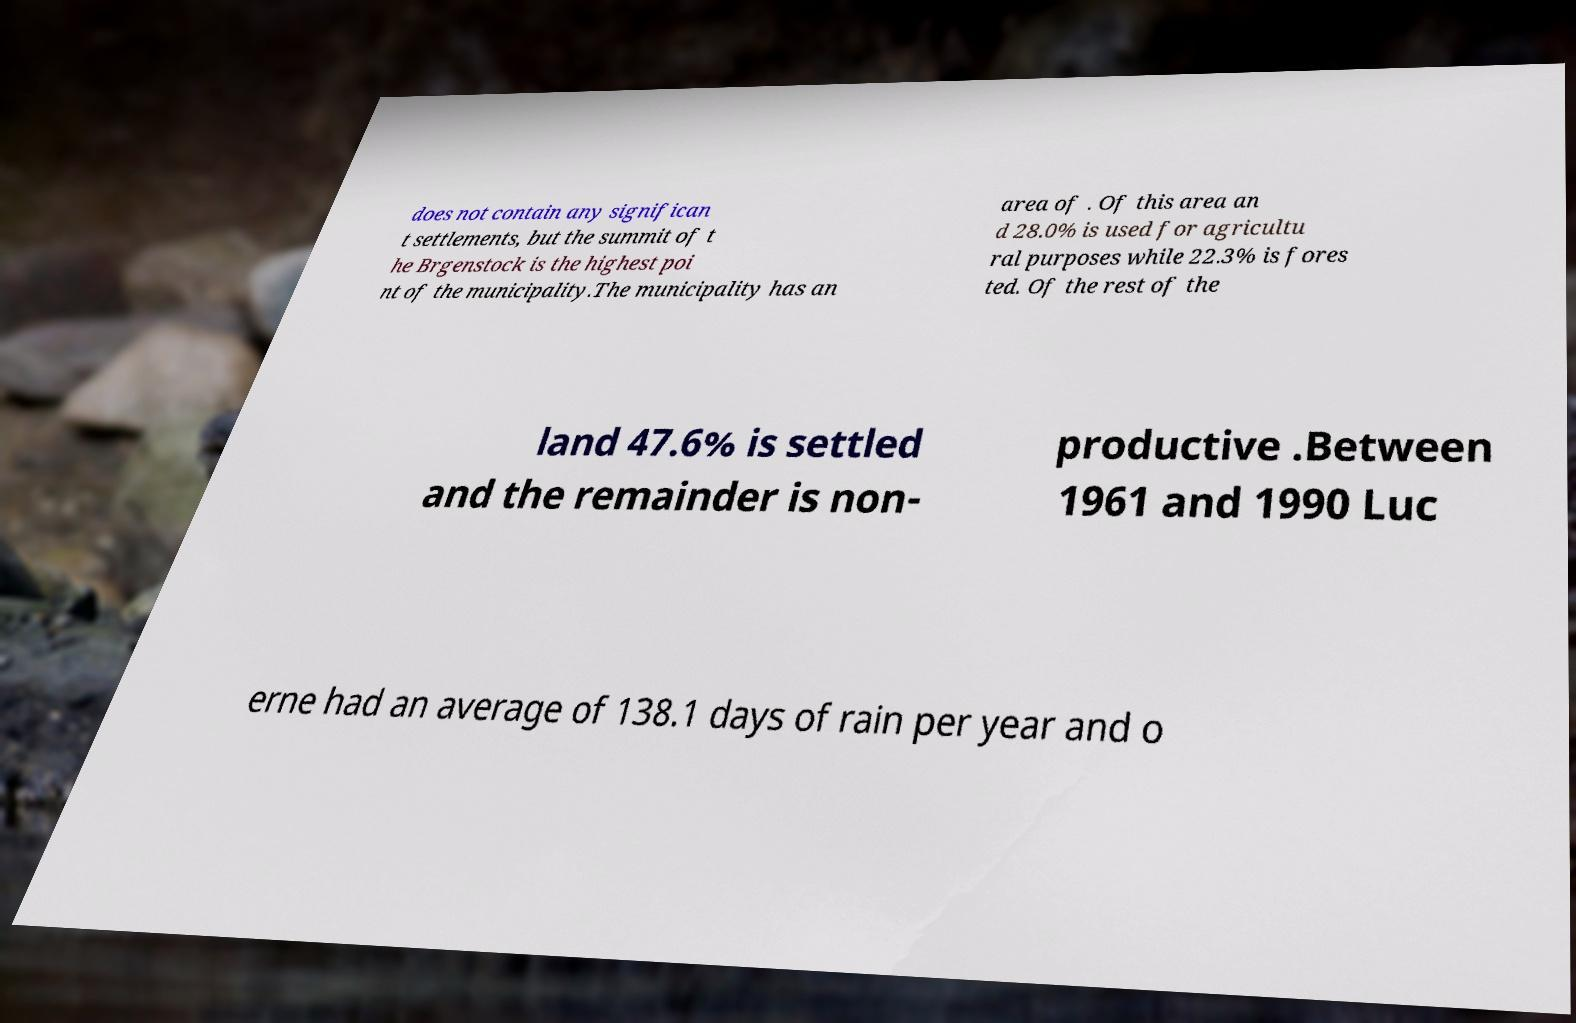Can you accurately transcribe the text from the provided image for me? does not contain any significan t settlements, but the summit of t he Brgenstock is the highest poi nt of the municipality.The municipality has an area of . Of this area an d 28.0% is used for agricultu ral purposes while 22.3% is fores ted. Of the rest of the land 47.6% is settled and the remainder is non- productive .Between 1961 and 1990 Luc erne had an average of 138.1 days of rain per year and o 